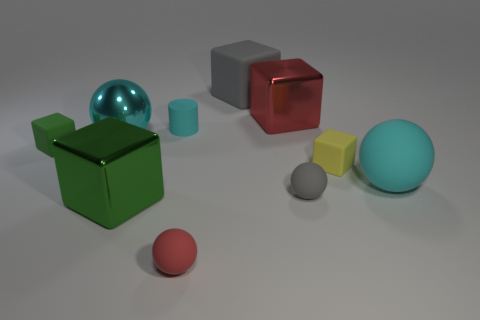Subtract all yellow cubes. How many cubes are left? 4 Subtract all gray spheres. How many green cubes are left? 2 Subtract 3 cubes. How many cubes are left? 2 Subtract all cyan spheres. How many spheres are left? 2 Subtract all cylinders. How many objects are left? 9 Add 2 big cyan metal objects. How many big cyan metal objects exist? 3 Subtract 0 blue cylinders. How many objects are left? 10 Subtract all blue cylinders. Subtract all cyan balls. How many cylinders are left? 1 Subtract all matte blocks. Subtract all cyan cubes. How many objects are left? 7 Add 4 tiny green rubber objects. How many tiny green rubber objects are left? 5 